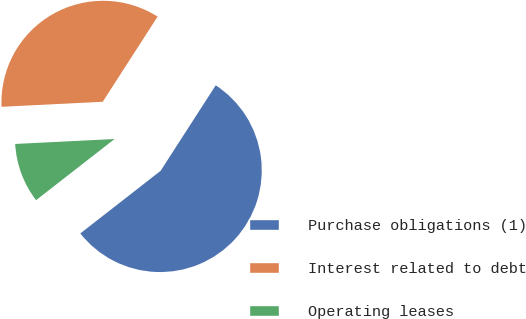Convert chart. <chart><loc_0><loc_0><loc_500><loc_500><pie_chart><fcel>Purchase obligations (1)<fcel>Interest related to debt<fcel>Operating leases<nl><fcel>55.35%<fcel>34.9%<fcel>9.75%<nl></chart> 